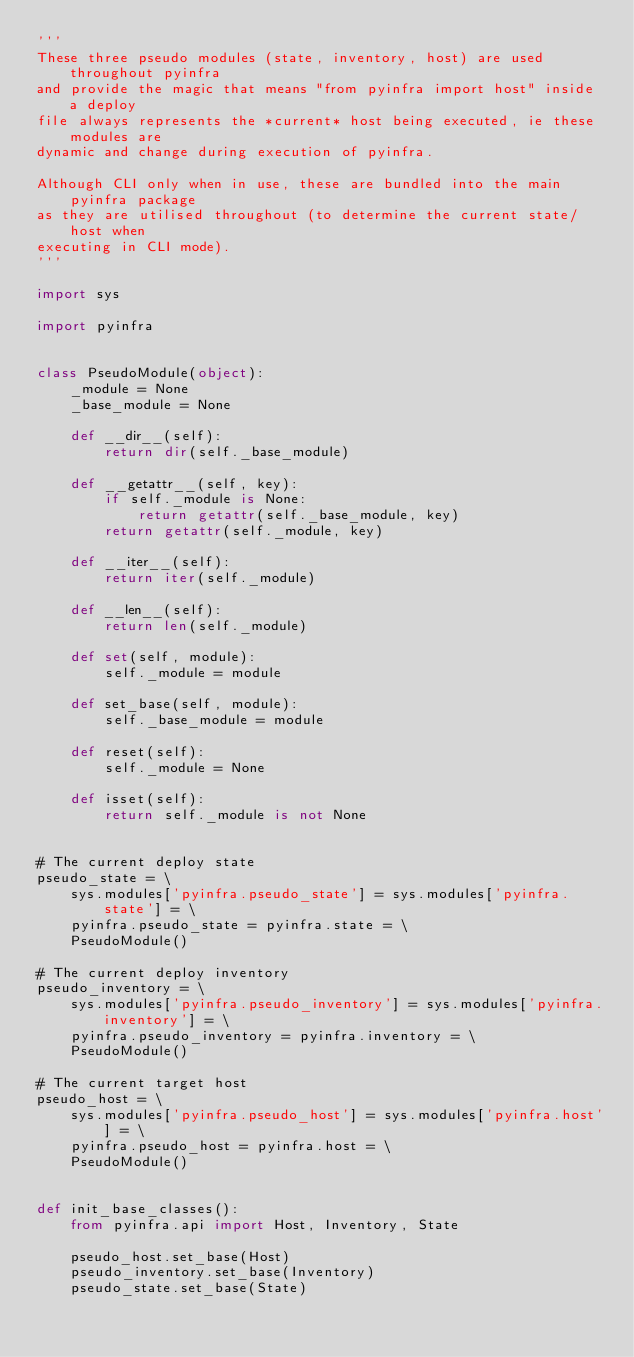Convert code to text. <code><loc_0><loc_0><loc_500><loc_500><_Python_>'''
These three pseudo modules (state, inventory, host) are used throughout pyinfra
and provide the magic that means "from pyinfra import host" inside a deploy
file always represents the *current* host being executed, ie these modules are
dynamic and change during execution of pyinfra.

Although CLI only when in use, these are bundled into the main pyinfra package
as they are utilised throughout (to determine the current state/host when
executing in CLI mode).
'''

import sys

import pyinfra


class PseudoModule(object):
    _module = None
    _base_module = None

    def __dir__(self):
        return dir(self._base_module)

    def __getattr__(self, key):
        if self._module is None:
            return getattr(self._base_module, key)
        return getattr(self._module, key)

    def __iter__(self):
        return iter(self._module)

    def __len__(self):
        return len(self._module)

    def set(self, module):
        self._module = module

    def set_base(self, module):
        self._base_module = module

    def reset(self):
        self._module = None

    def isset(self):
        return self._module is not None


# The current deploy state
pseudo_state = \
    sys.modules['pyinfra.pseudo_state'] = sys.modules['pyinfra.state'] = \
    pyinfra.pseudo_state = pyinfra.state = \
    PseudoModule()

# The current deploy inventory
pseudo_inventory = \
    sys.modules['pyinfra.pseudo_inventory'] = sys.modules['pyinfra.inventory'] = \
    pyinfra.pseudo_inventory = pyinfra.inventory = \
    PseudoModule()

# The current target host
pseudo_host = \
    sys.modules['pyinfra.pseudo_host'] = sys.modules['pyinfra.host'] = \
    pyinfra.pseudo_host = pyinfra.host = \
    PseudoModule()


def init_base_classes():
    from pyinfra.api import Host, Inventory, State

    pseudo_host.set_base(Host)
    pseudo_inventory.set_base(Inventory)
    pseudo_state.set_base(State)
</code> 